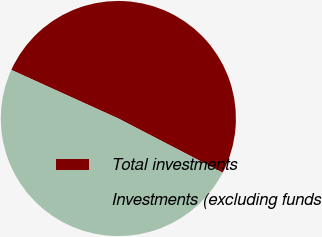<chart> <loc_0><loc_0><loc_500><loc_500><pie_chart><fcel>Total investments<fcel>Investments (excluding funds<nl><fcel>50.84%<fcel>49.16%<nl></chart> 